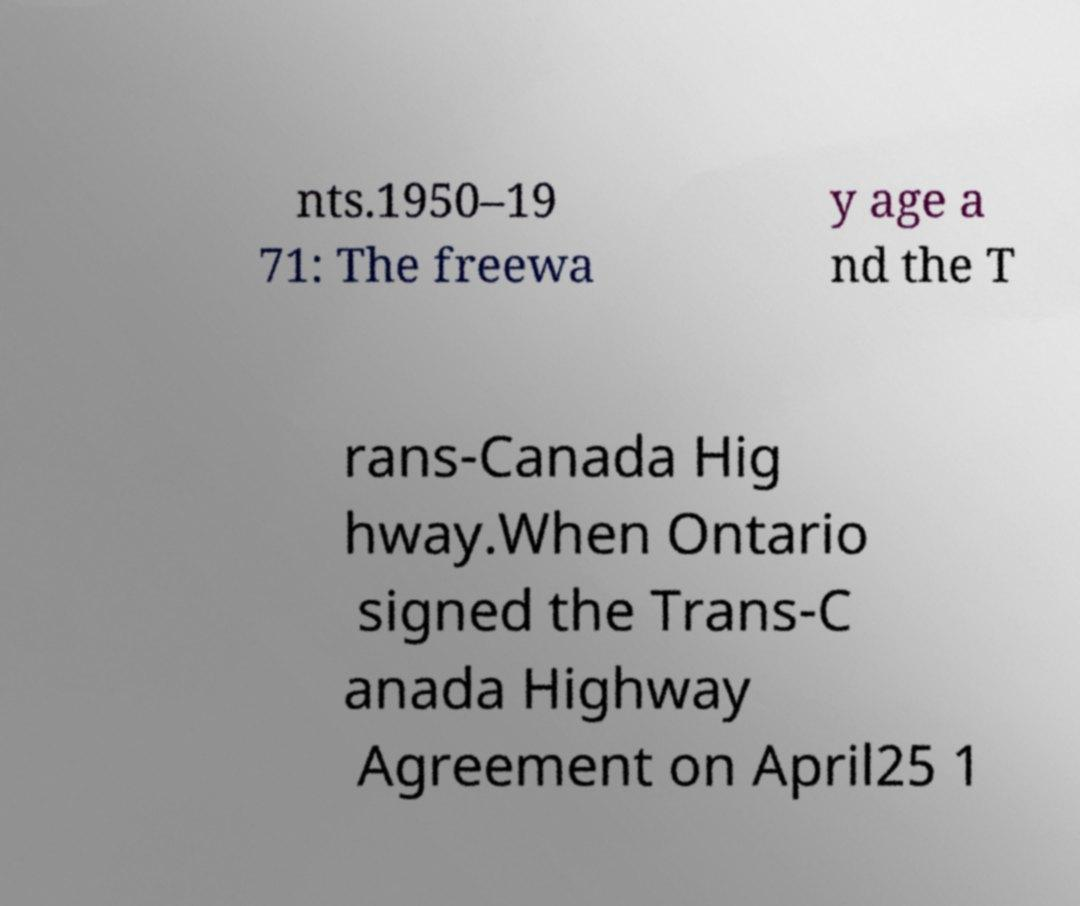Can you read and provide the text displayed in the image?This photo seems to have some interesting text. Can you extract and type it out for me? nts.1950–19 71: The freewa y age a nd the T rans-Canada Hig hway.When Ontario signed the Trans-C anada Highway Agreement on April25 1 